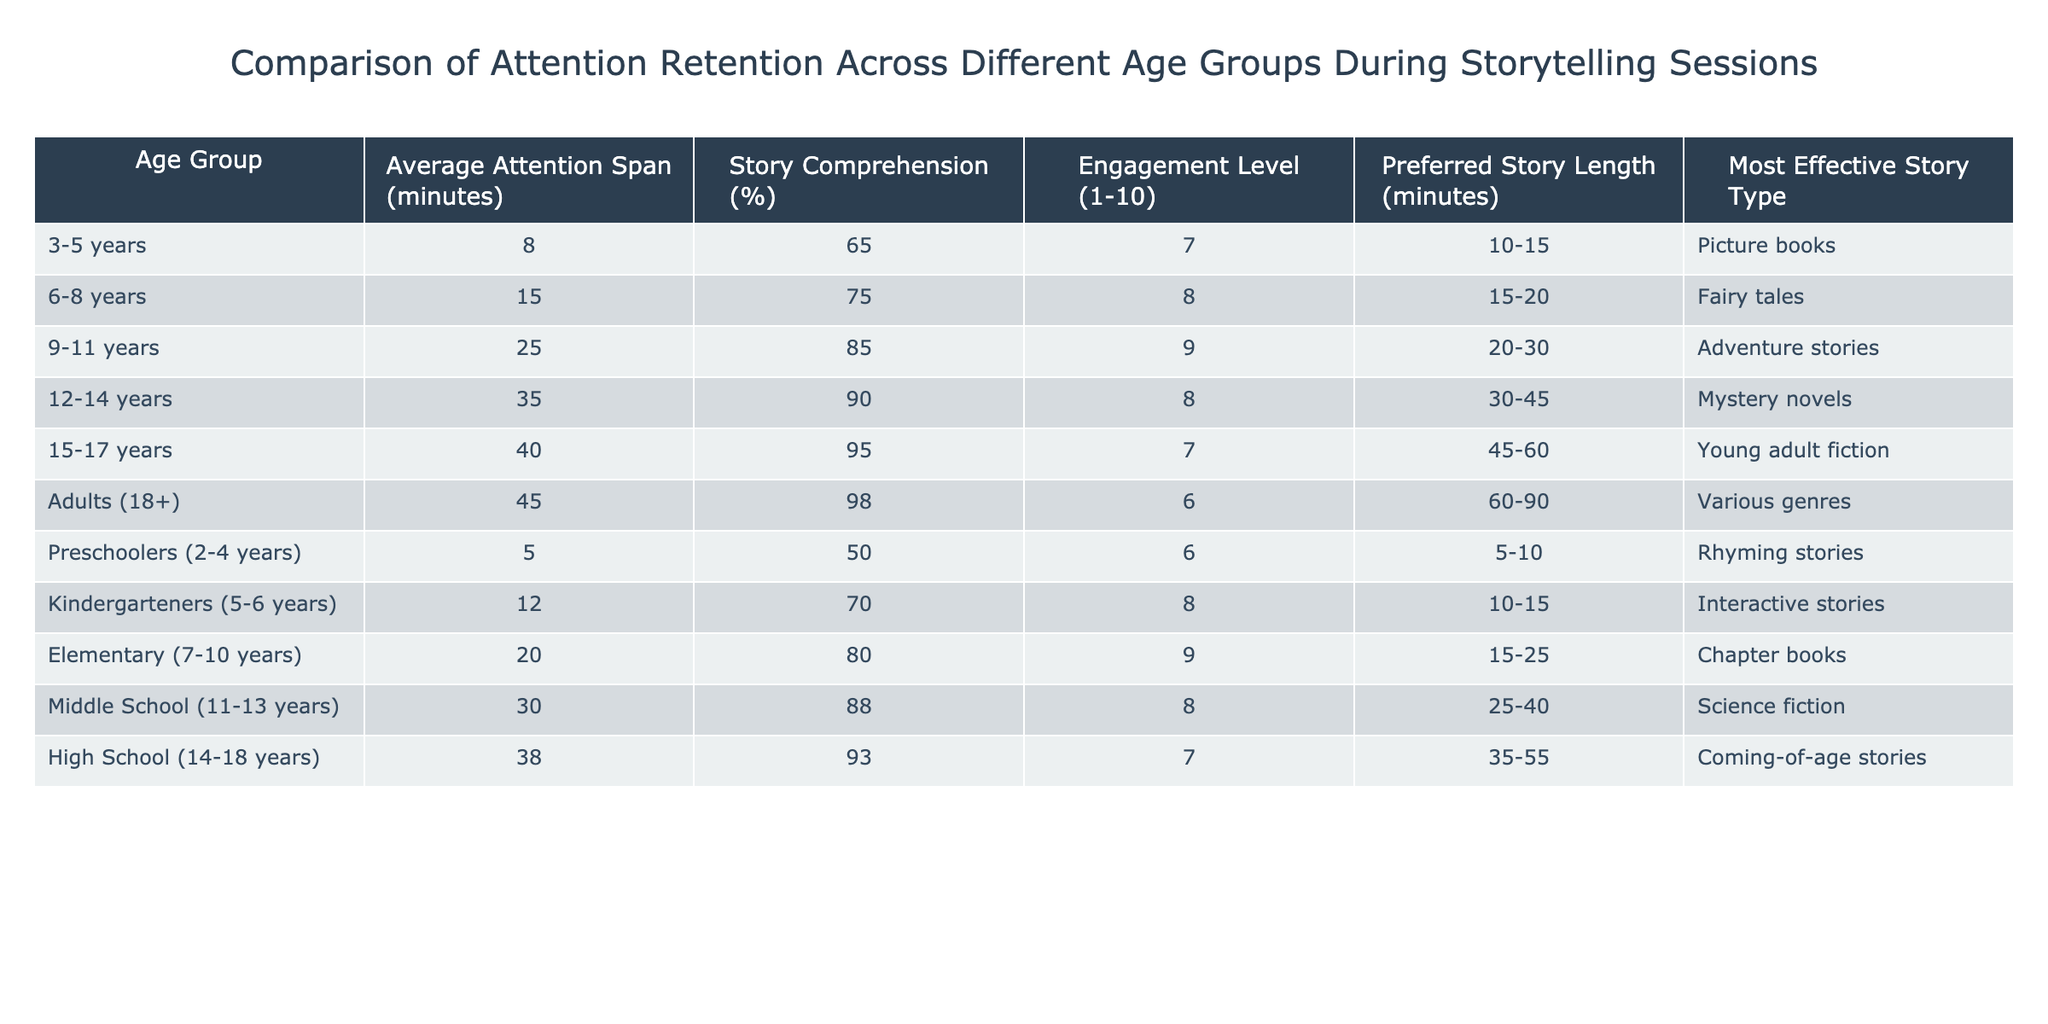What is the average attention span for the age group 3-5 years? The average attention span listed in the table for the 3-5 years age group is 8 minutes.
Answer: 8 minutes Which age group has the highest story comprehension percentage? The table shows that the age group 15-17 years has the highest story comprehension percentage at 95%.
Answer: 15-17 years Is the preferred story length for preschoolers (2-4 years) longer than that for kindergarteners (5-6 years)? The preferred story length for preschoolers is 5-10 minutes, while for kindergarteners it is 10-15 minutes. Since 10-15 minutes is longer than 5-10 minutes, the statement is false.
Answer: No What is the difference in average attention span between adults (18+) and middle schoolers (11-13 years)? The average attention span for adults (18+) is 45 minutes, and for middle schoolers (11-13 years), it is 30 minutes. The difference is 45 minutes - 30 minutes = 15 minutes.
Answer: 15 minutes How many age groups have an average attention span of less than 20 minutes? The age groups with an average attention span of less than 20 minutes are 3-5 years (8 minutes), preschoolers (5 minutes), and kindergarteners (12 minutes). There are a total of 3 age groups fitting this criterion.
Answer: 3 age groups What is the most effective story type for the age group 9-11 years? According to the table, the most effective story type for the 9-11 years age group is adventure stories.
Answer: Adventure stories Does the engagement level decrease as the age group increases? Reviewing the engagement levels in the table: 7, 8, 9, 8, 7, and 6 for each age group respectively show that the engagement level fluctuates but generally decreases from 9 to 6 across the age groups. So, the statement is true.
Answer: Yes What is the average story comprehension for the elementary age group (7-10 years)? The average story comprehension for the elementary age group (7-10 years) is given in the table as 80%.
Answer: 80% 